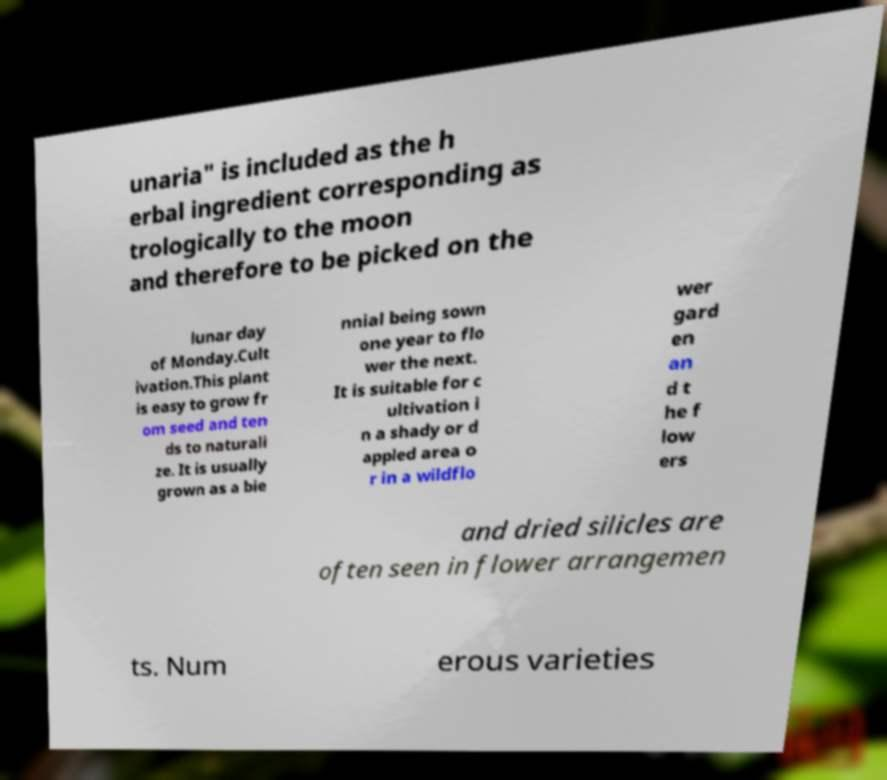For documentation purposes, I need the text within this image transcribed. Could you provide that? unaria" is included as the h erbal ingredient corresponding as trologically to the moon and therefore to be picked on the lunar day of Monday.Cult ivation.This plant is easy to grow fr om seed and ten ds to naturali ze. It is usually grown as a bie nnial being sown one year to flo wer the next. It is suitable for c ultivation i n a shady or d appled area o r in a wildflo wer gard en an d t he f low ers and dried silicles are often seen in flower arrangemen ts. Num erous varieties 